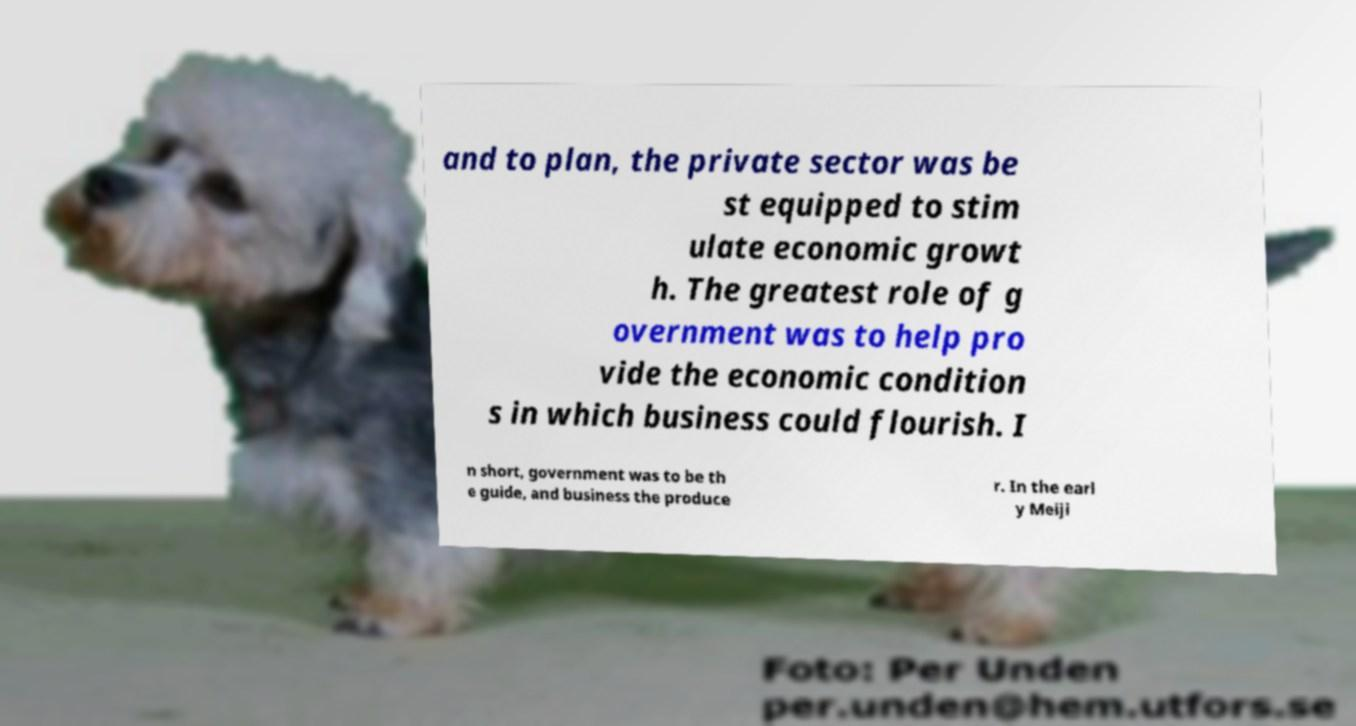Please read and relay the text visible in this image. What does it say? and to plan, the private sector was be st equipped to stim ulate economic growt h. The greatest role of g overnment was to help pro vide the economic condition s in which business could flourish. I n short, government was to be th e guide, and business the produce r. In the earl y Meiji 